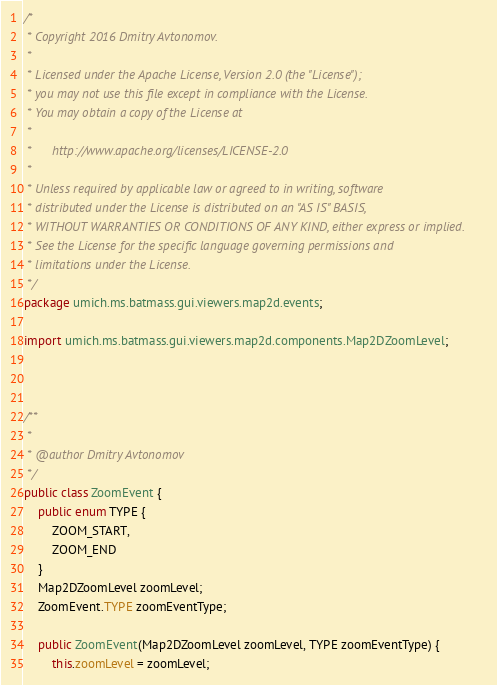<code> <loc_0><loc_0><loc_500><loc_500><_Java_>/* 
 * Copyright 2016 Dmitry Avtonomov.
 *
 * Licensed under the Apache License, Version 2.0 (the "License");
 * you may not use this file except in compliance with the License.
 * You may obtain a copy of the License at
 *
 *      http://www.apache.org/licenses/LICENSE-2.0
 *
 * Unless required by applicable law or agreed to in writing, software
 * distributed under the License is distributed on an "AS IS" BASIS,
 * WITHOUT WARRANTIES OR CONDITIONS OF ANY KIND, either express or implied.
 * See the License for the specific language governing permissions and
 * limitations under the License.
 */
package umich.ms.batmass.gui.viewers.map2d.events;

import umich.ms.batmass.gui.viewers.map2d.components.Map2DZoomLevel;



/**
 *
 * @author Dmitry Avtonomov
 */
public class ZoomEvent {
    public enum TYPE {
        ZOOM_START,
        ZOOM_END
    }
    Map2DZoomLevel zoomLevel;
    ZoomEvent.TYPE zoomEventType;

    public ZoomEvent(Map2DZoomLevel zoomLevel, TYPE zoomEventType) {
        this.zoomLevel = zoomLevel;</code> 